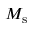Convert formula to latex. <formula><loc_0><loc_0><loc_500><loc_500>M _ { s }</formula> 